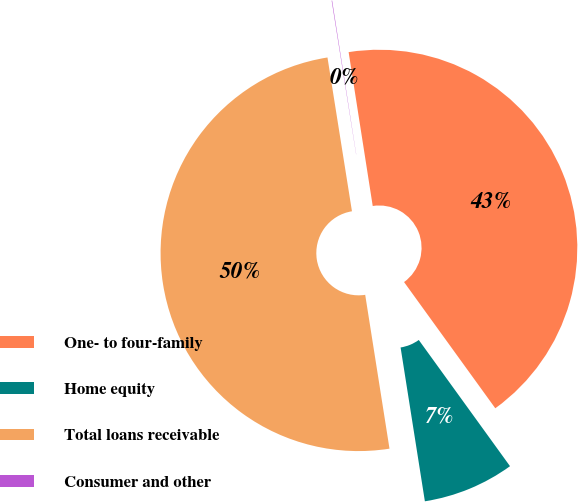Convert chart. <chart><loc_0><loc_0><loc_500><loc_500><pie_chart><fcel>One- to four-family<fcel>Home equity<fcel>Total loans receivable<fcel>Consumer and other<nl><fcel>42.51%<fcel>7.47%<fcel>49.98%<fcel>0.04%<nl></chart> 